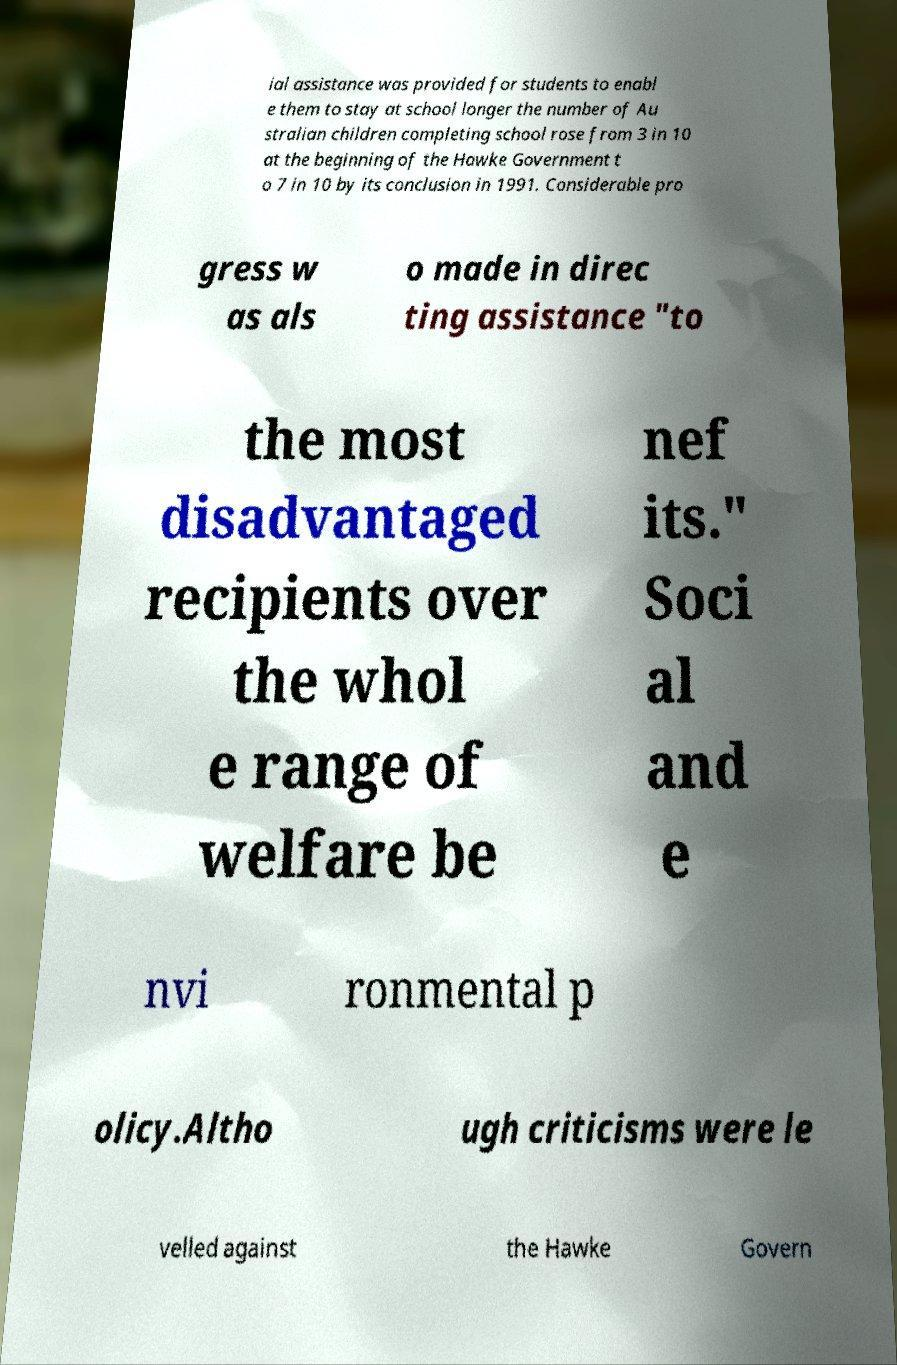Please read and relay the text visible in this image. What does it say? ial assistance was provided for students to enabl e them to stay at school longer the number of Au stralian children completing school rose from 3 in 10 at the beginning of the Hawke Government t o 7 in 10 by its conclusion in 1991. Considerable pro gress w as als o made in direc ting assistance "to the most disadvantaged recipients over the whol e range of welfare be nef its." Soci al and e nvi ronmental p olicy.Altho ugh criticisms were le velled against the Hawke Govern 